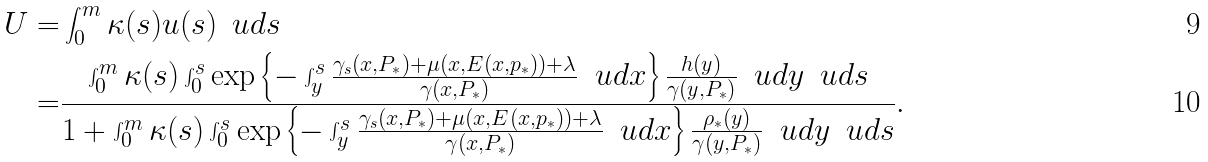<formula> <loc_0><loc_0><loc_500><loc_500>U = & \int _ { 0 } ^ { m } \kappa ( s ) u ( s ) \, \ u d s \\ = & \frac { \int _ { 0 } ^ { m } \kappa ( s ) \int _ { 0 } ^ { s } \exp \left \{ - \int _ { y } ^ { s } \frac { \gamma _ { s } ( x , P _ { * } ) + \mu ( x , E ( x , p _ { * } ) ) + \lambda } { \gamma ( x , P _ { * } ) } \, \ u d x \right \} \frac { h ( y ) } { \gamma ( y , P _ { * } ) } \, \ u d y \, \ u d s } { 1 + \int _ { 0 } ^ { m } \kappa ( s ) \int _ { 0 } ^ { s } \exp \left \{ - \int _ { y } ^ { s } \frac { \gamma _ { s } ( x , P _ { * } ) + \mu ( x , E ( x , p _ { * } ) ) + \lambda } { \gamma ( x , P _ { * } ) } \, \ u d x \right \} \frac { \rho _ { * } ( y ) } { \gamma ( y , P _ { * } ) } \, \ u d y \, \ u d s } .</formula> 